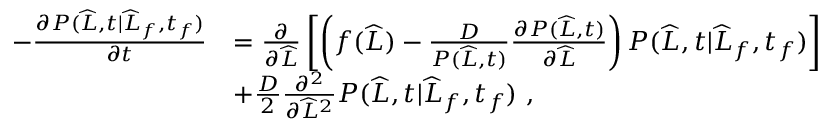Convert formula to latex. <formula><loc_0><loc_0><loc_500><loc_500>\begin{array} { r l } { - \frac { \partial P ( \widehat { L } , t | \widehat { L } _ { f } , t _ { f } ) } { \partial t } } & { = \frac { \partial } { \partial \widehat { L } } \left [ \left ( f ( \widehat { L } ) - \frac { D } { P ( \widehat { L } , t ) } \frac { \partial P ( \widehat { L } , t ) } { \partial \widehat { L } } \right ) P ( \widehat { L } , t | \widehat { L } _ { f } , t _ { f } ) \right ] } \\ & { + \frac { D } { 2 } \frac { \partial ^ { 2 } } { \partial \widehat { L } ^ { 2 } } P ( \widehat { L } , t | \widehat { L } _ { f } , t _ { f } ) \ , } \end{array}</formula> 